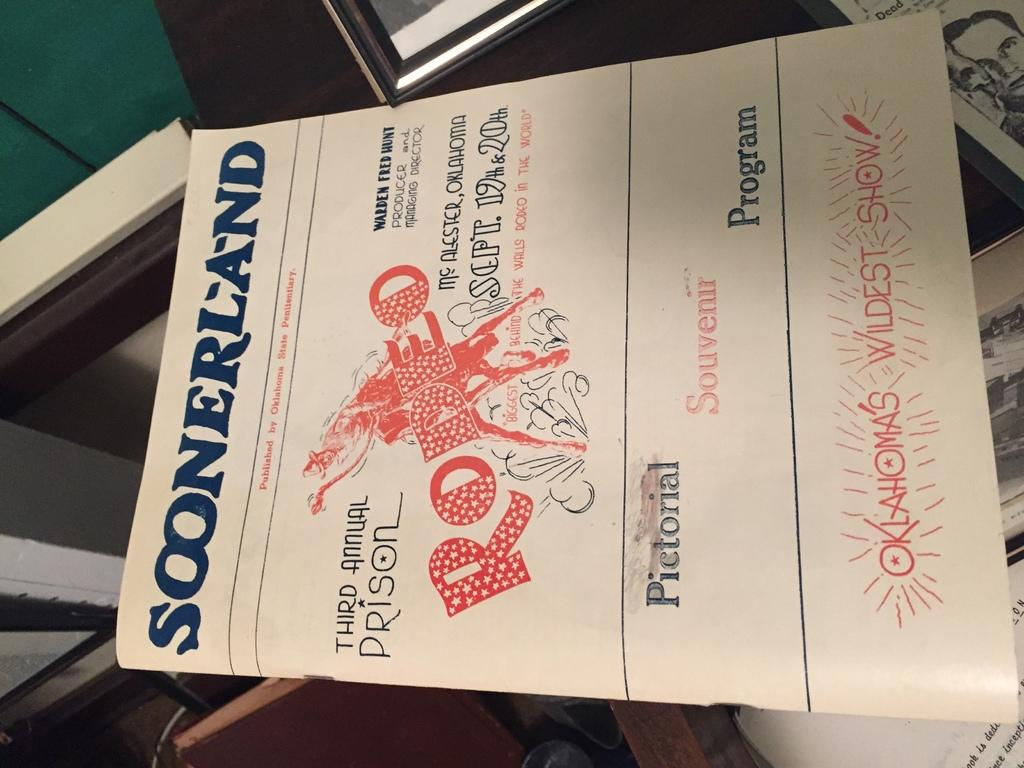<image>
Render a clear and concise summary of the photo. A show program bears the name Soonerland up top. 